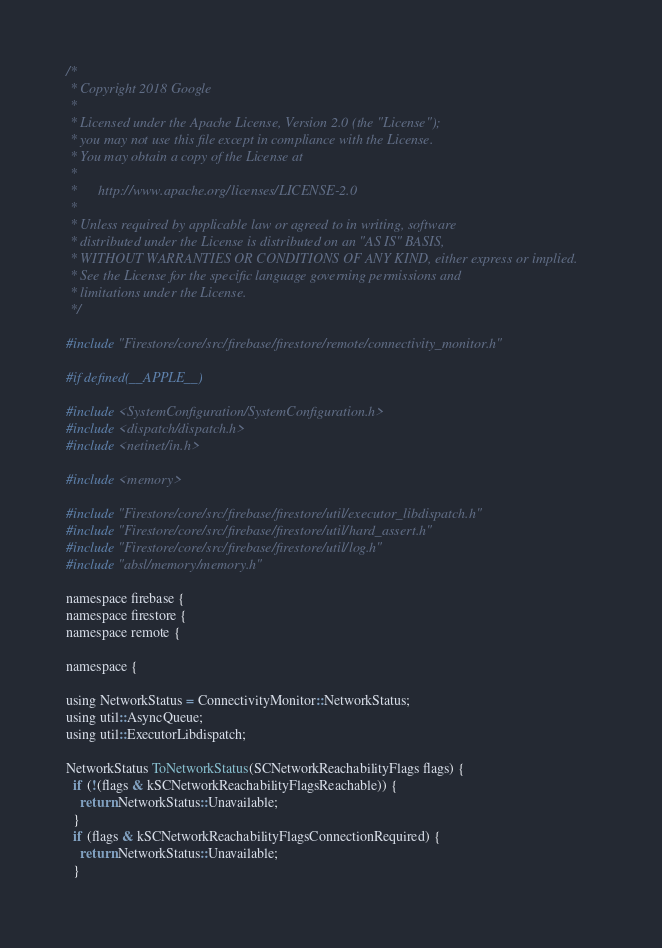<code> <loc_0><loc_0><loc_500><loc_500><_ObjectiveC_>/*
 * Copyright 2018 Google
 *
 * Licensed under the Apache License, Version 2.0 (the "License");
 * you may not use this file except in compliance with the License.
 * You may obtain a copy of the License at
 *
 *      http://www.apache.org/licenses/LICENSE-2.0
 *
 * Unless required by applicable law or agreed to in writing, software
 * distributed under the License is distributed on an "AS IS" BASIS,
 * WITHOUT WARRANTIES OR CONDITIONS OF ANY KIND, either express or implied.
 * See the License for the specific language governing permissions and
 * limitations under the License.
 */

#include "Firestore/core/src/firebase/firestore/remote/connectivity_monitor.h"

#if defined(__APPLE__)

#include <SystemConfiguration/SystemConfiguration.h>
#include <dispatch/dispatch.h>
#include <netinet/in.h>

#include <memory>

#include "Firestore/core/src/firebase/firestore/util/executor_libdispatch.h"
#include "Firestore/core/src/firebase/firestore/util/hard_assert.h"
#include "Firestore/core/src/firebase/firestore/util/log.h"
#include "absl/memory/memory.h"

namespace firebase {
namespace firestore {
namespace remote {

namespace {

using NetworkStatus = ConnectivityMonitor::NetworkStatus;
using util::AsyncQueue;
using util::ExecutorLibdispatch;

NetworkStatus ToNetworkStatus(SCNetworkReachabilityFlags flags) {
  if (!(flags & kSCNetworkReachabilityFlagsReachable)) {
    return NetworkStatus::Unavailable;
  }
  if (flags & kSCNetworkReachabilityFlagsConnectionRequired) {
    return NetworkStatus::Unavailable;
  }
</code> 